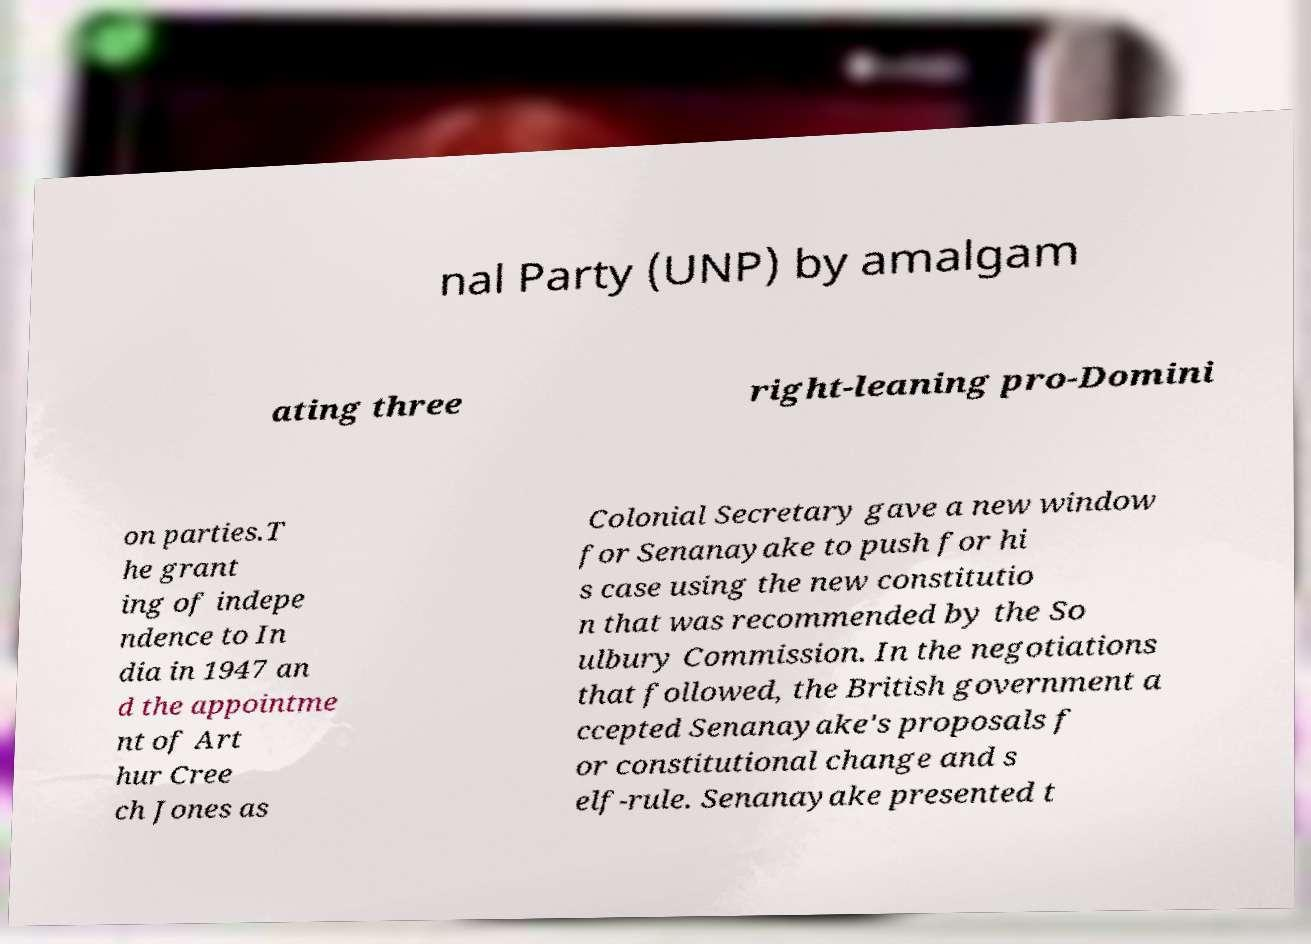Could you extract and type out the text from this image? nal Party (UNP) by amalgam ating three right-leaning pro-Domini on parties.T he grant ing of indepe ndence to In dia in 1947 an d the appointme nt of Art hur Cree ch Jones as Colonial Secretary gave a new window for Senanayake to push for hi s case using the new constitutio n that was recommended by the So ulbury Commission. In the negotiations that followed, the British government a ccepted Senanayake's proposals f or constitutional change and s elf-rule. Senanayake presented t 